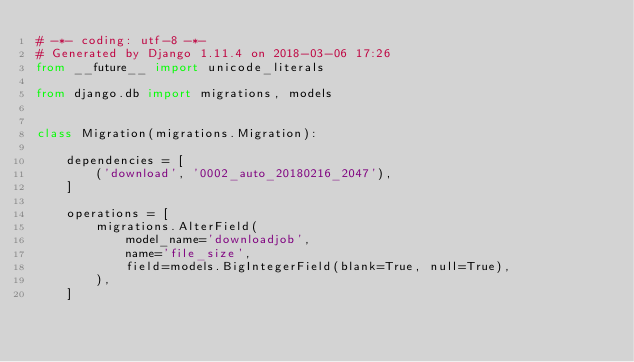<code> <loc_0><loc_0><loc_500><loc_500><_Python_># -*- coding: utf-8 -*-
# Generated by Django 1.11.4 on 2018-03-06 17:26
from __future__ import unicode_literals

from django.db import migrations, models


class Migration(migrations.Migration):

    dependencies = [
        ('download', '0002_auto_20180216_2047'),
    ]

    operations = [
        migrations.AlterField(
            model_name='downloadjob',
            name='file_size',
            field=models.BigIntegerField(blank=True, null=True),
        ),
    ]
</code> 